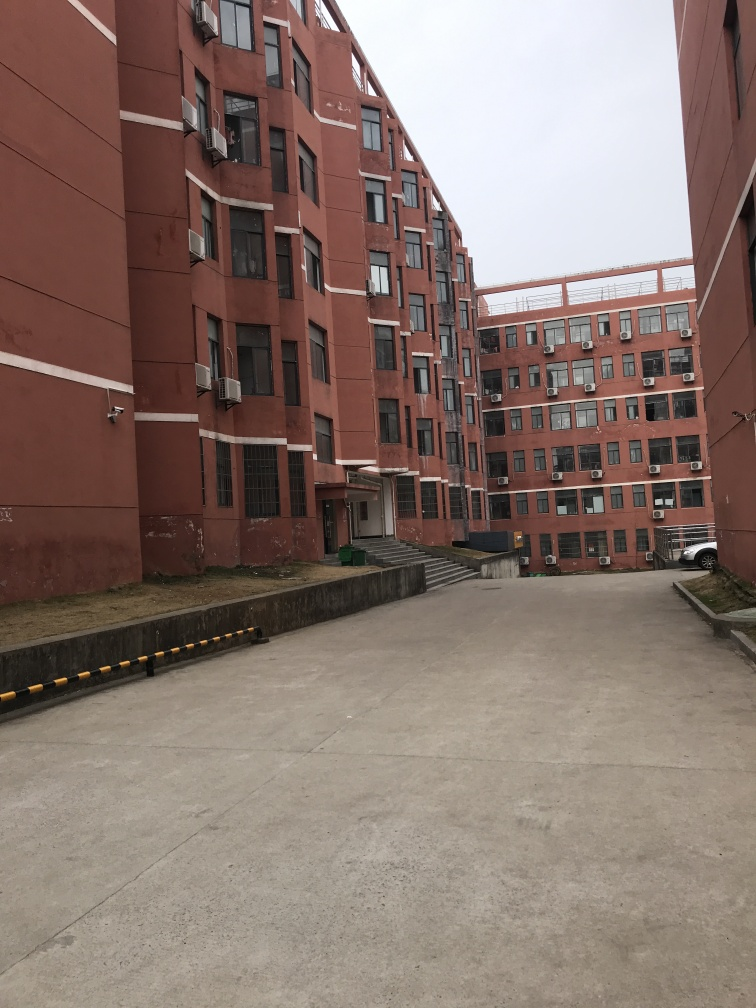Can you describe the environment shown in this image? The image depicts an urban living environment, likely an apartment complex. The building's facade is a reddish-brown color with white windows, many of which have air conditioning units. The building appears functional and residential, with a no-nonsense, utilitarian design. A concrete walkway with yellow-black barricades leads up to the entrance, suggesting some consideration for traffic regulation and pedestrian safety. What can you tell me about the weather or time of day in the image? The sky is overcast, indicating either an early morning before the sun fully rises, a cloudy day, or an evening as the light begins to fade. There are no shadows or bright sunlight visible, which usually suggests a lack of direct sunlight and thus reinforces the possibility of an overcast or cloudy sky. 